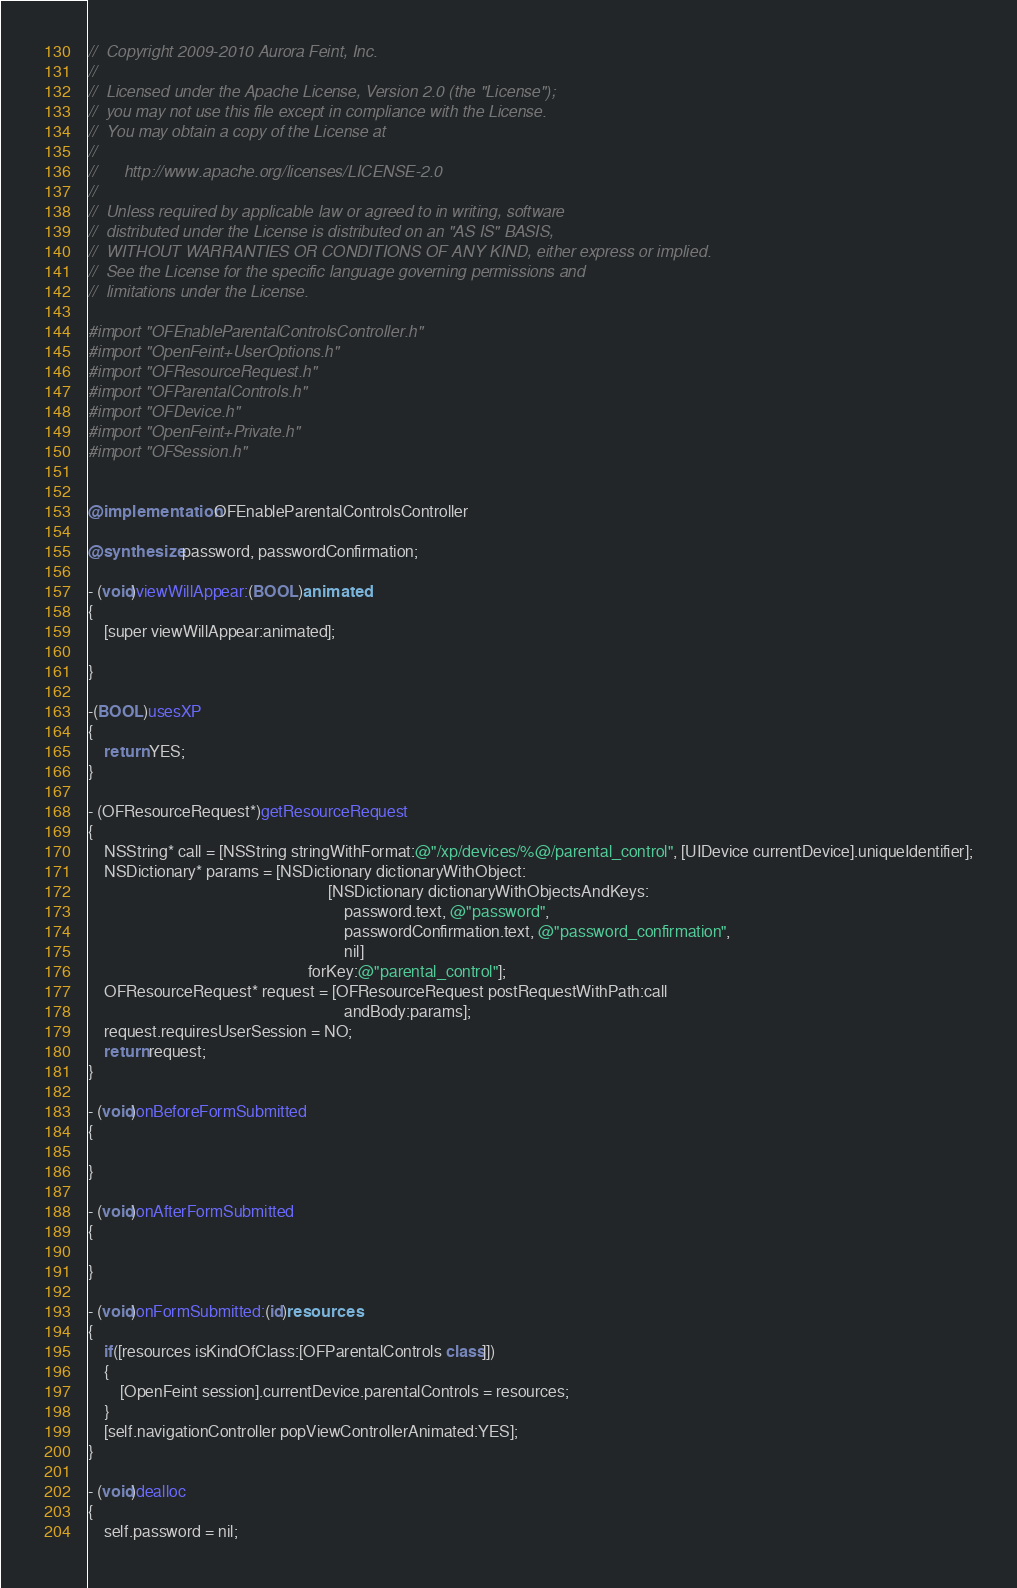Convert code to text. <code><loc_0><loc_0><loc_500><loc_500><_ObjectiveC_>//  Copyright 2009-2010 Aurora Feint, Inc.
// 
//  Licensed under the Apache License, Version 2.0 (the "License");
//  you may not use this file except in compliance with the License.
//  You may obtain a copy of the License at
//  
//  	http://www.apache.org/licenses/LICENSE-2.0
//  	
//  Unless required by applicable law or agreed to in writing, software
//  distributed under the License is distributed on an "AS IS" BASIS,
//  WITHOUT WARRANTIES OR CONDITIONS OF ANY KIND, either express or implied.
//  See the License for the specific language governing permissions and
//  limitations under the License.

#import "OFEnableParentalControlsController.h"
#import "OpenFeint+UserOptions.h"
#import "OFResourceRequest.h"
#import "OFParentalControls.h"
#import "OFDevice.h"
#import "OpenFeint+Private.h"
#import "OFSession.h"


@implementation OFEnableParentalControlsController

@synthesize password, passwordConfirmation;

- (void)viewWillAppear:(BOOL)animated
{
	[super viewWillAppear:animated];

}

-(BOOL)usesXP
{
	return YES;
}

- (OFResourceRequest*)getResourceRequest
{
	NSString* call = [NSString stringWithFormat:@"/xp/devices/%@/parental_control", [UIDevice currentDevice].uniqueIdentifier];
	NSDictionary* params = [NSDictionary dictionaryWithObject:
															[NSDictionary dictionaryWithObjectsAndKeys:
																password.text, @"password",
																passwordConfirmation.text, @"password_confirmation",
																nil]
													   forKey:@"parental_control"];
	OFResourceRequest* request = [OFResourceRequest postRequestWithPath:call
																andBody:params];
	request.requiresUserSession = NO;
	return request; 
}

- (void)onBeforeFormSubmitted
{

}

- (void)onAfterFormSubmitted
{
	
}

- (void)onFormSubmitted:(id)resources
{
	if([resources isKindOfClass:[OFParentalControls class]])
	{
		[OpenFeint session].currentDevice.parentalControls = resources;
	}
	[self.navigationController popViewControllerAnimated:YES];
}

- (void)dealloc
{
	self.password = nil;</code> 